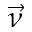Convert formula to latex. <formula><loc_0><loc_0><loc_500><loc_500>\vec { \nu }</formula> 